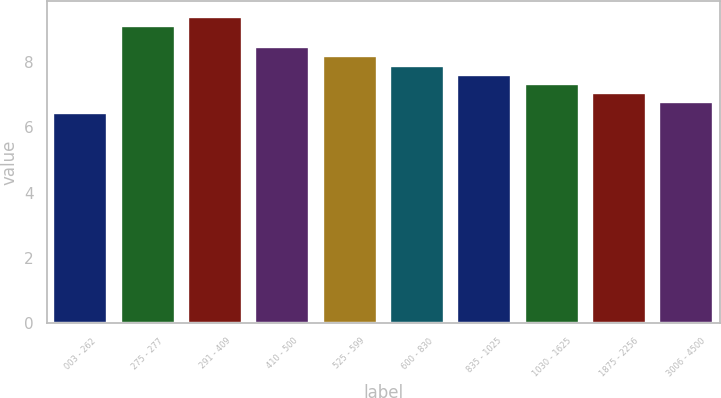<chart> <loc_0><loc_0><loc_500><loc_500><bar_chart><fcel>003 - 262<fcel>275 - 277<fcel>291 - 409<fcel>410 - 500<fcel>525 - 599<fcel>600 - 830<fcel>835 - 1025<fcel>1030 - 1625<fcel>1875 - 2256<fcel>3006 - 4500<nl><fcel>6.45<fcel>9.12<fcel>9.4<fcel>8.46<fcel>8.18<fcel>7.9<fcel>7.62<fcel>7.34<fcel>7.06<fcel>6.78<nl></chart> 